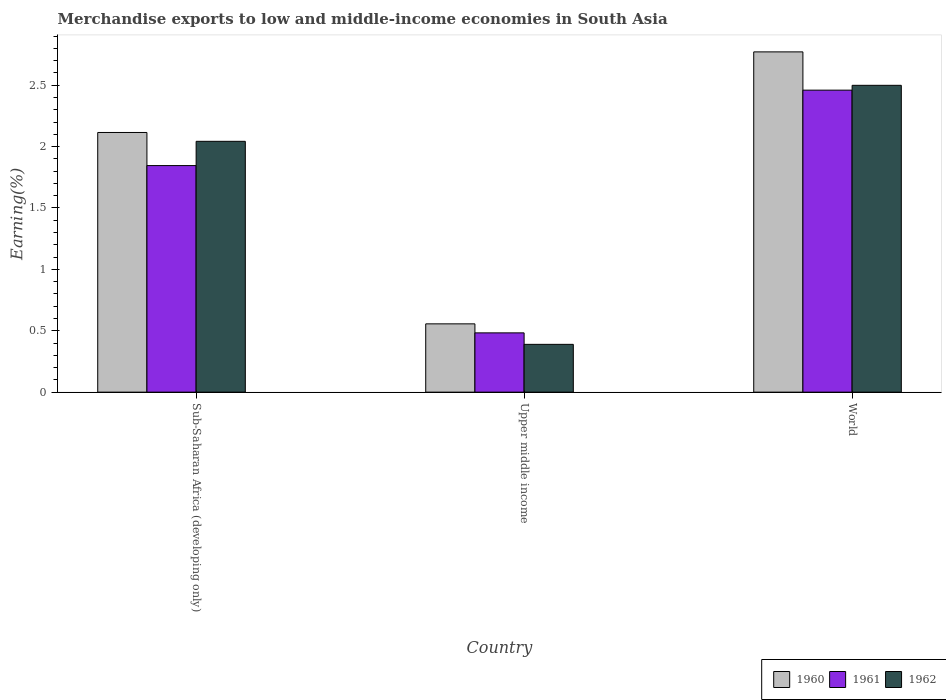How many different coloured bars are there?
Provide a succinct answer. 3. Are the number of bars per tick equal to the number of legend labels?
Offer a terse response. Yes. Are the number of bars on each tick of the X-axis equal?
Give a very brief answer. Yes. How many bars are there on the 2nd tick from the left?
Make the answer very short. 3. How many bars are there on the 2nd tick from the right?
Keep it short and to the point. 3. What is the label of the 1st group of bars from the left?
Provide a succinct answer. Sub-Saharan Africa (developing only). In how many cases, is the number of bars for a given country not equal to the number of legend labels?
Your response must be concise. 0. What is the percentage of amount earned from merchandise exports in 1962 in Sub-Saharan Africa (developing only)?
Make the answer very short. 2.04. Across all countries, what is the maximum percentage of amount earned from merchandise exports in 1962?
Offer a terse response. 2.5. Across all countries, what is the minimum percentage of amount earned from merchandise exports in 1962?
Make the answer very short. 0.39. In which country was the percentage of amount earned from merchandise exports in 1962 maximum?
Your answer should be compact. World. In which country was the percentage of amount earned from merchandise exports in 1960 minimum?
Keep it short and to the point. Upper middle income. What is the total percentage of amount earned from merchandise exports in 1960 in the graph?
Keep it short and to the point. 5.44. What is the difference between the percentage of amount earned from merchandise exports in 1960 in Sub-Saharan Africa (developing only) and that in World?
Make the answer very short. -0.66. What is the difference between the percentage of amount earned from merchandise exports in 1960 in World and the percentage of amount earned from merchandise exports in 1961 in Sub-Saharan Africa (developing only)?
Make the answer very short. 0.93. What is the average percentage of amount earned from merchandise exports in 1962 per country?
Your answer should be compact. 1.64. What is the difference between the percentage of amount earned from merchandise exports of/in 1960 and percentage of amount earned from merchandise exports of/in 1961 in Upper middle income?
Provide a succinct answer. 0.07. What is the ratio of the percentage of amount earned from merchandise exports in 1960 in Sub-Saharan Africa (developing only) to that in World?
Give a very brief answer. 0.76. Is the difference between the percentage of amount earned from merchandise exports in 1960 in Sub-Saharan Africa (developing only) and Upper middle income greater than the difference between the percentage of amount earned from merchandise exports in 1961 in Sub-Saharan Africa (developing only) and Upper middle income?
Your response must be concise. Yes. What is the difference between the highest and the second highest percentage of amount earned from merchandise exports in 1962?
Make the answer very short. -2.11. What is the difference between the highest and the lowest percentage of amount earned from merchandise exports in 1961?
Keep it short and to the point. 1.98. In how many countries, is the percentage of amount earned from merchandise exports in 1962 greater than the average percentage of amount earned from merchandise exports in 1962 taken over all countries?
Give a very brief answer. 2. Is the sum of the percentage of amount earned from merchandise exports in 1962 in Sub-Saharan Africa (developing only) and Upper middle income greater than the maximum percentage of amount earned from merchandise exports in 1961 across all countries?
Provide a succinct answer. No. What does the 3rd bar from the left in World represents?
Make the answer very short. 1962. What does the 2nd bar from the right in Upper middle income represents?
Offer a very short reply. 1961. How many bars are there?
Ensure brevity in your answer.  9. Are all the bars in the graph horizontal?
Provide a succinct answer. No. How many countries are there in the graph?
Your answer should be very brief. 3. What is the difference between two consecutive major ticks on the Y-axis?
Keep it short and to the point. 0.5. Are the values on the major ticks of Y-axis written in scientific E-notation?
Make the answer very short. No. Does the graph contain any zero values?
Give a very brief answer. No. Does the graph contain grids?
Offer a terse response. No. Where does the legend appear in the graph?
Give a very brief answer. Bottom right. How are the legend labels stacked?
Provide a short and direct response. Horizontal. What is the title of the graph?
Ensure brevity in your answer.  Merchandise exports to low and middle-income economies in South Asia. Does "2014" appear as one of the legend labels in the graph?
Your answer should be very brief. No. What is the label or title of the Y-axis?
Ensure brevity in your answer.  Earning(%). What is the Earning(%) in 1960 in Sub-Saharan Africa (developing only)?
Offer a terse response. 2.11. What is the Earning(%) of 1961 in Sub-Saharan Africa (developing only)?
Provide a succinct answer. 1.85. What is the Earning(%) of 1962 in Sub-Saharan Africa (developing only)?
Ensure brevity in your answer.  2.04. What is the Earning(%) of 1960 in Upper middle income?
Your answer should be very brief. 0.56. What is the Earning(%) of 1961 in Upper middle income?
Your answer should be compact. 0.48. What is the Earning(%) of 1962 in Upper middle income?
Provide a short and direct response. 0.39. What is the Earning(%) in 1960 in World?
Offer a terse response. 2.77. What is the Earning(%) of 1961 in World?
Provide a succinct answer. 2.46. What is the Earning(%) of 1962 in World?
Your answer should be very brief. 2.5. Across all countries, what is the maximum Earning(%) of 1960?
Your answer should be compact. 2.77. Across all countries, what is the maximum Earning(%) of 1961?
Make the answer very short. 2.46. Across all countries, what is the maximum Earning(%) in 1962?
Your answer should be very brief. 2.5. Across all countries, what is the minimum Earning(%) in 1960?
Provide a succinct answer. 0.56. Across all countries, what is the minimum Earning(%) in 1961?
Your answer should be compact. 0.48. Across all countries, what is the minimum Earning(%) in 1962?
Ensure brevity in your answer.  0.39. What is the total Earning(%) in 1960 in the graph?
Your response must be concise. 5.44. What is the total Earning(%) of 1961 in the graph?
Keep it short and to the point. 4.79. What is the total Earning(%) in 1962 in the graph?
Provide a succinct answer. 4.93. What is the difference between the Earning(%) in 1960 in Sub-Saharan Africa (developing only) and that in Upper middle income?
Make the answer very short. 1.56. What is the difference between the Earning(%) of 1961 in Sub-Saharan Africa (developing only) and that in Upper middle income?
Ensure brevity in your answer.  1.36. What is the difference between the Earning(%) of 1962 in Sub-Saharan Africa (developing only) and that in Upper middle income?
Give a very brief answer. 1.65. What is the difference between the Earning(%) of 1960 in Sub-Saharan Africa (developing only) and that in World?
Your response must be concise. -0.66. What is the difference between the Earning(%) in 1961 in Sub-Saharan Africa (developing only) and that in World?
Offer a terse response. -0.61. What is the difference between the Earning(%) in 1962 in Sub-Saharan Africa (developing only) and that in World?
Ensure brevity in your answer.  -0.46. What is the difference between the Earning(%) of 1960 in Upper middle income and that in World?
Offer a very short reply. -2.21. What is the difference between the Earning(%) in 1961 in Upper middle income and that in World?
Offer a terse response. -1.98. What is the difference between the Earning(%) of 1962 in Upper middle income and that in World?
Ensure brevity in your answer.  -2.11. What is the difference between the Earning(%) in 1960 in Sub-Saharan Africa (developing only) and the Earning(%) in 1961 in Upper middle income?
Your answer should be very brief. 1.63. What is the difference between the Earning(%) of 1960 in Sub-Saharan Africa (developing only) and the Earning(%) of 1962 in Upper middle income?
Provide a short and direct response. 1.73. What is the difference between the Earning(%) in 1961 in Sub-Saharan Africa (developing only) and the Earning(%) in 1962 in Upper middle income?
Give a very brief answer. 1.46. What is the difference between the Earning(%) of 1960 in Sub-Saharan Africa (developing only) and the Earning(%) of 1961 in World?
Keep it short and to the point. -0.34. What is the difference between the Earning(%) in 1960 in Sub-Saharan Africa (developing only) and the Earning(%) in 1962 in World?
Your answer should be compact. -0.38. What is the difference between the Earning(%) in 1961 in Sub-Saharan Africa (developing only) and the Earning(%) in 1962 in World?
Offer a very short reply. -0.65. What is the difference between the Earning(%) of 1960 in Upper middle income and the Earning(%) of 1961 in World?
Your answer should be compact. -1.9. What is the difference between the Earning(%) of 1960 in Upper middle income and the Earning(%) of 1962 in World?
Ensure brevity in your answer.  -1.94. What is the difference between the Earning(%) of 1961 in Upper middle income and the Earning(%) of 1962 in World?
Your answer should be very brief. -2.02. What is the average Earning(%) in 1960 per country?
Your response must be concise. 1.81. What is the average Earning(%) in 1961 per country?
Give a very brief answer. 1.6. What is the average Earning(%) of 1962 per country?
Keep it short and to the point. 1.64. What is the difference between the Earning(%) of 1960 and Earning(%) of 1961 in Sub-Saharan Africa (developing only)?
Keep it short and to the point. 0.27. What is the difference between the Earning(%) of 1960 and Earning(%) of 1962 in Sub-Saharan Africa (developing only)?
Your response must be concise. 0.07. What is the difference between the Earning(%) of 1961 and Earning(%) of 1962 in Sub-Saharan Africa (developing only)?
Offer a terse response. -0.2. What is the difference between the Earning(%) of 1960 and Earning(%) of 1961 in Upper middle income?
Offer a terse response. 0.07. What is the difference between the Earning(%) in 1960 and Earning(%) in 1962 in Upper middle income?
Offer a terse response. 0.17. What is the difference between the Earning(%) in 1961 and Earning(%) in 1962 in Upper middle income?
Provide a succinct answer. 0.09. What is the difference between the Earning(%) in 1960 and Earning(%) in 1961 in World?
Make the answer very short. 0.31. What is the difference between the Earning(%) in 1960 and Earning(%) in 1962 in World?
Provide a short and direct response. 0.27. What is the difference between the Earning(%) of 1961 and Earning(%) of 1962 in World?
Keep it short and to the point. -0.04. What is the ratio of the Earning(%) in 1960 in Sub-Saharan Africa (developing only) to that in Upper middle income?
Offer a very short reply. 3.8. What is the ratio of the Earning(%) in 1961 in Sub-Saharan Africa (developing only) to that in Upper middle income?
Ensure brevity in your answer.  3.82. What is the ratio of the Earning(%) in 1962 in Sub-Saharan Africa (developing only) to that in Upper middle income?
Your response must be concise. 5.25. What is the ratio of the Earning(%) of 1960 in Sub-Saharan Africa (developing only) to that in World?
Your answer should be very brief. 0.76. What is the ratio of the Earning(%) in 1961 in Sub-Saharan Africa (developing only) to that in World?
Keep it short and to the point. 0.75. What is the ratio of the Earning(%) in 1962 in Sub-Saharan Africa (developing only) to that in World?
Keep it short and to the point. 0.82. What is the ratio of the Earning(%) of 1960 in Upper middle income to that in World?
Your response must be concise. 0.2. What is the ratio of the Earning(%) in 1961 in Upper middle income to that in World?
Ensure brevity in your answer.  0.2. What is the ratio of the Earning(%) in 1962 in Upper middle income to that in World?
Make the answer very short. 0.16. What is the difference between the highest and the second highest Earning(%) of 1960?
Keep it short and to the point. 0.66. What is the difference between the highest and the second highest Earning(%) in 1961?
Offer a very short reply. 0.61. What is the difference between the highest and the second highest Earning(%) of 1962?
Your response must be concise. 0.46. What is the difference between the highest and the lowest Earning(%) of 1960?
Provide a succinct answer. 2.21. What is the difference between the highest and the lowest Earning(%) of 1961?
Provide a short and direct response. 1.98. What is the difference between the highest and the lowest Earning(%) in 1962?
Offer a very short reply. 2.11. 